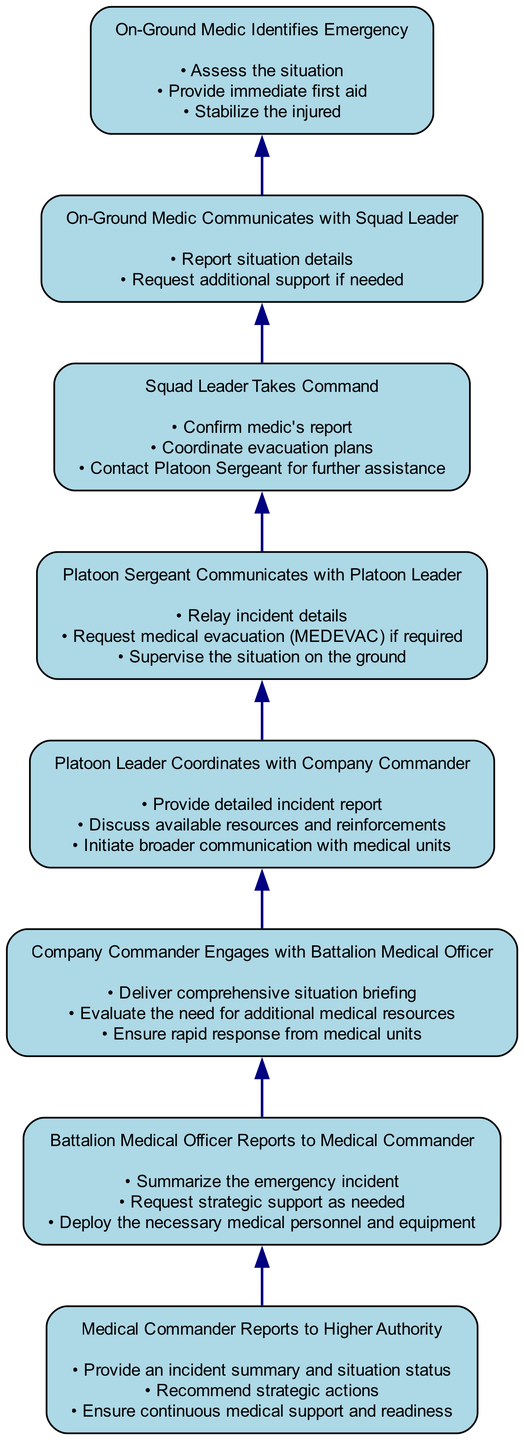What is the first step in the flowchart? The flowchart begins with the "On-Ground Medic Identifies Emergency," which is the initial action during a medical emergency. This is the first node, indicating where the process starts.
Answer: On-Ground Medic Identifies Emergency How many total steps are in the flowchart? By counting the individual steps listed in the data (elements), we find that there are a total of eight distinct actions in the flowchart, allowing us to determine the length of the chain of command in emergency medical response.
Answer: Eight What follows after the "Squad Leader Takes Command"? From the diagram flow, after "Squad Leader Takes Command," the next step is "Platoon Sergeant Communicates with Platoon Leader." This can be derived by following the directional edges connecting the nodes.
Answer: Platoon Sergeant Communicates with Platoon Leader What actions does the "On-Ground Medic Identifies Emergency" include? The actions listed under the "On-Ground Medic Identifies Emergency" node are "Assess the situation," "Provide immediate first aid," and "Stabilize the injured." These actions are crucial for an appropriate initial response to a medical emergency.
Answer: Assess the situation, Provide immediate first aid, Stabilize the injured Which step involves the coordination of evacuation plans? The step "Squad Leader Takes Command" directly includes actions that involve coordinating evacuation plans. This is indicated in the list of actions associated with this node.
Answer: Squad Leader Takes Command What does the "Battalion Medical Officer Reports to Medical Commander" entail? This node encompasses actions such as summarizing the emergency incident, requesting strategic support, and deploying necessary medical personnel and equipment. It indicates what is required to transition the situation up the chain to the Medical Commander.
Answer: Summarize the emergency incident, Request strategic support, Deploy necessary medical personnel and equipment Which node initiates broader communication with medical units? The step "Platoon Leader Coordinates with Company Commander" initiates broader communication with medical units, as it includes discussing available resources and reinforcements and providing a detailed incident report which leads to further contact with medical units.
Answer: Platoon Leader Coordinates with Company Commander What is the last action before the Medical Commander Reports to Higher Authority? The last action before "Medical Commander Reports to Higher Authority" is "Battalion Medical Officer Reports to Medical Commander." This shows the direct progression leading to the final reporting in the chain of command.
Answer: Battalion Medical Officer Reports to Medical Commander 